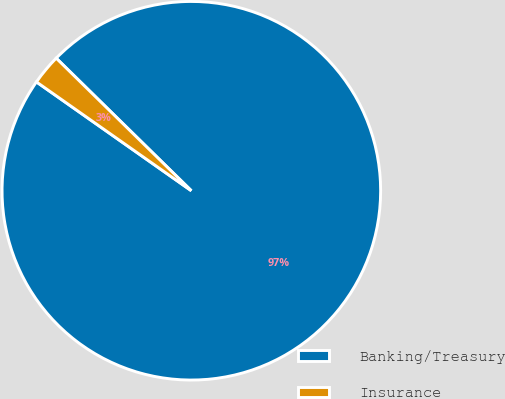Convert chart. <chart><loc_0><loc_0><loc_500><loc_500><pie_chart><fcel>Banking/Treasury<fcel>Insurance<nl><fcel>97.4%<fcel>2.6%<nl></chart> 